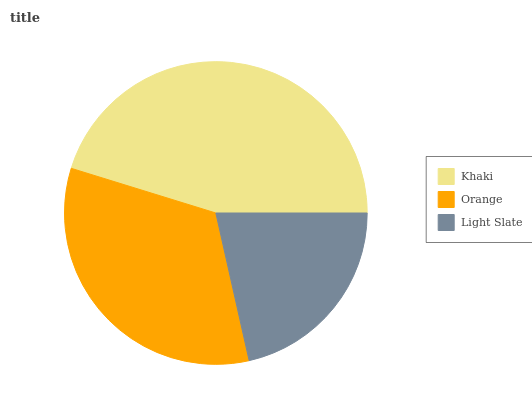Is Light Slate the minimum?
Answer yes or no. Yes. Is Khaki the maximum?
Answer yes or no. Yes. Is Orange the minimum?
Answer yes or no. No. Is Orange the maximum?
Answer yes or no. No. Is Khaki greater than Orange?
Answer yes or no. Yes. Is Orange less than Khaki?
Answer yes or no. Yes. Is Orange greater than Khaki?
Answer yes or no. No. Is Khaki less than Orange?
Answer yes or no. No. Is Orange the high median?
Answer yes or no. Yes. Is Orange the low median?
Answer yes or no. Yes. Is Light Slate the high median?
Answer yes or no. No. Is Khaki the low median?
Answer yes or no. No. 